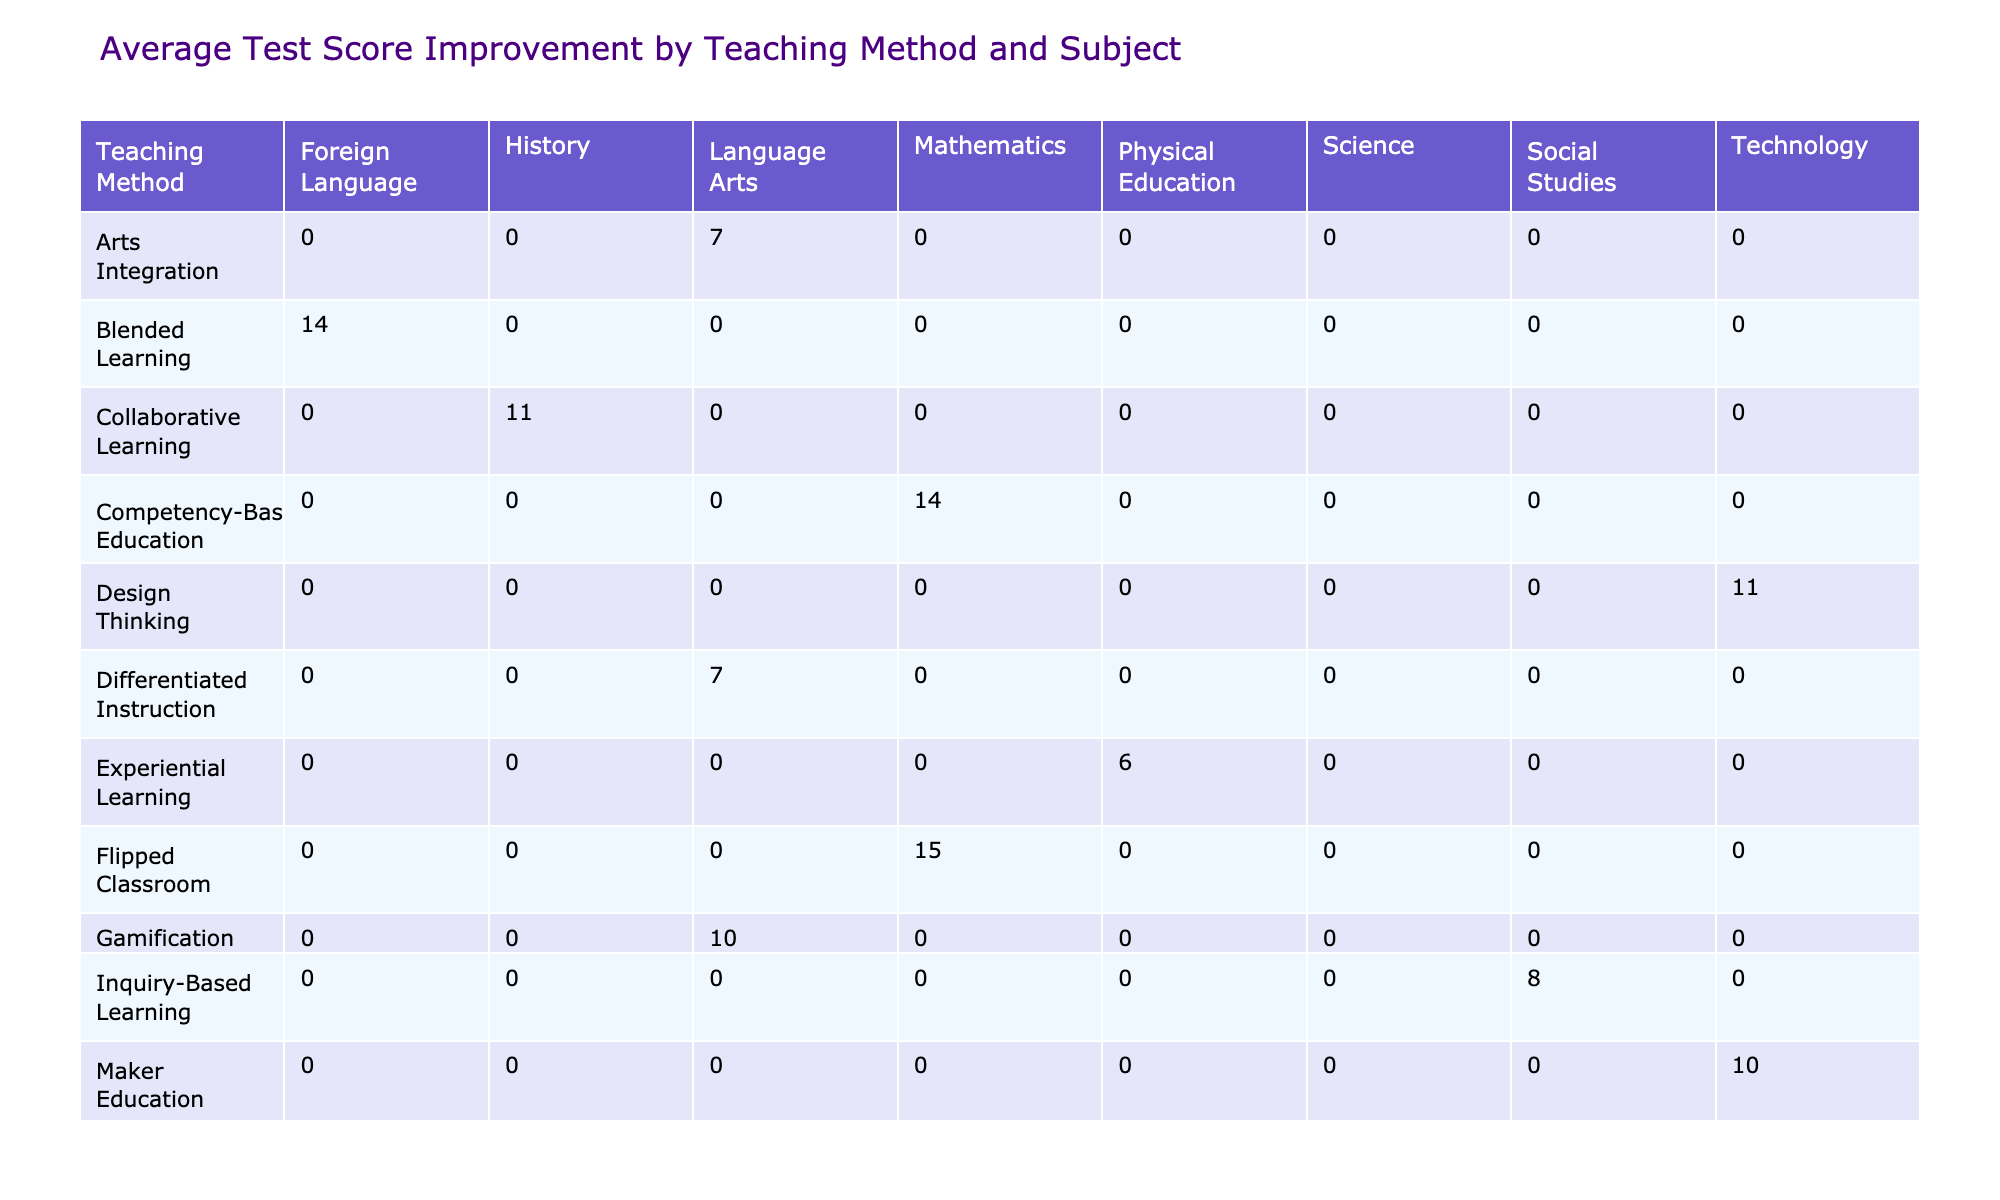What is the average test score improvement for Project-Based Learning in Science? The table shows the Test Score Improvement values for Project-Based Learning under the Science subject is 12. Therefore, the average test score improvement is directly taken from this entry.
Answer: 12 Which teaching method had the highest average test score improvement in Mathematics? The table lists the average test score improvements for Mathematics: Flipped Classroom (15), Personalized Learning (12), and Competency-Based Education (14). The highest average is 15 from the Flipped Classroom.
Answer: Flipped Classroom Is the average test score improvement for Inquiry-Based Learning in Social Studies greater than that for Arts Integration in Language Arts? The average test score improvement for Inquiry-Based Learning in Social Studies is 8, while for Arts Integration in Language Arts, it is 7. Since 8 is greater than 7, the statement is true.
Answer: Yes What is the total test score improvement for all teaching methods in Science? The table shows the test score improvements for Science: Project-Based Learning (12), Problem-Based Learning (9), and Peer Instruction (11). Summing these gives 12 + 9 + 11 = 32 for total test score improvement in Science.
Answer: 32 Which subject had the lowest average test score improvement, and what is that value? By reviewing the average test score improvement: Science's average is 10.67, Mathematics is 13.75, and Social Studies is 8.25. The lowest average is in Social Studies with a value of 8.25.
Answer: Social Studies, 8.25 How many teaching methods have an average attendance rate greater than 95%? The attendance rates above 95% come from the following methods: Project-Based Learning (95%) and Experiential Learning (98%). Thus, there are two methods exceeding a 95% attendance rate.
Answer: 2 What is the difference in average test score improvement between Gamification and Montessori Method? For Gamification, the average test score improvement is 10, while for the Montessori Method, it is 13. The difference is calculated as 13 - 10 = 3.
Answer: 3 Is the average creativity rating for Blended Learning higher than that for Gamification? The creativity rating for Blended Learning is 8, and for Gamification, it is 8. Both ratings are equal, thus the answer is no.
Answer: No What is the average test score improvement for all teaching methods combined? Reviewing the average for each method and summing the values: 12 (PBL) + 15 (Flipped) + 8 (Inquiry) + 10 (Gamification) + 14 (Blended) + 11 (Design Thinking) + 6 (Experiential) + 13 (Montessori) + 9 (Problem-Based) + 11 (Collaborative) + 7 (Differentiated) + 10 (Maker) + 12 (Personalized) + 8 (STEAM) + 9 (Socratic) + 13 (Mastery) + 7 (Arts) + 14 (Competency) + 11 (Peer) + 10 (Whole Brain) equals 15.
Answer: 10.67 